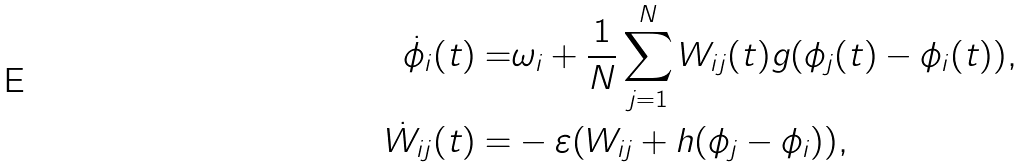Convert formula to latex. <formula><loc_0><loc_0><loc_500><loc_500>\dot { \phi } _ { i } ( t ) = & \omega _ { i } + \frac { 1 } { N } \sum _ { j = 1 } ^ { N } W _ { i j } ( t ) g ( \phi _ { j } ( t ) - \phi _ { i } ( t ) ) , \\ \dot { W } _ { i j } ( t ) = & - \varepsilon ( W _ { i j } + h ( \phi _ { j } - \phi _ { i } ) ) ,</formula> 